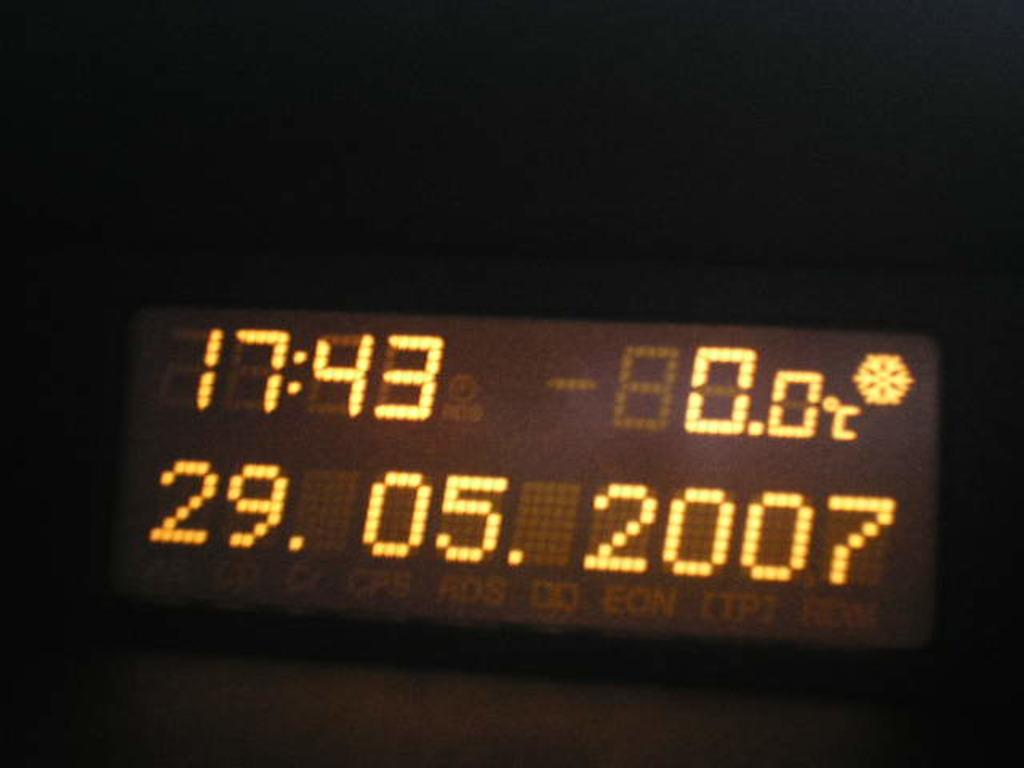<image>
Give a short and clear explanation of the subsequent image. A lighted display shows the date of 29.05.2007 and the time of 17:43. 